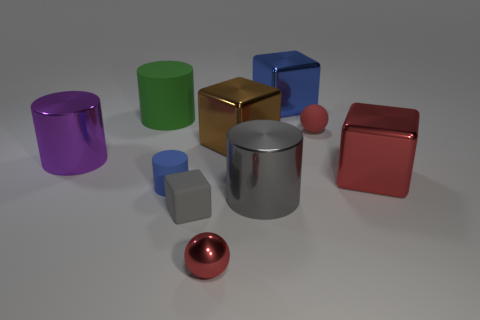Subtract all balls. How many objects are left? 8 Subtract 1 purple cylinders. How many objects are left? 9 Subtract all brown metallic blocks. Subtract all gray metallic objects. How many objects are left? 8 Add 5 large red objects. How many large red objects are left? 6 Add 3 red balls. How many red balls exist? 5 